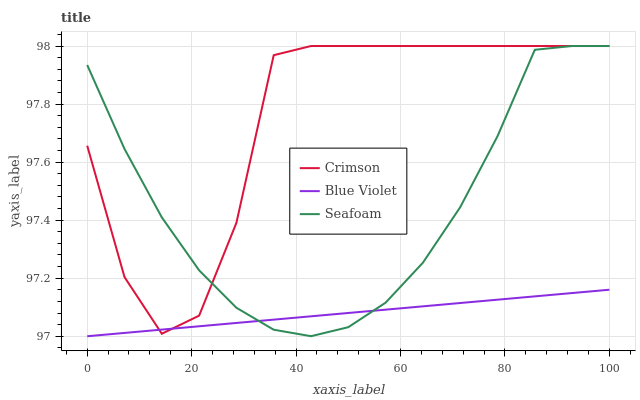Does Blue Violet have the minimum area under the curve?
Answer yes or no. Yes. Does Crimson have the maximum area under the curve?
Answer yes or no. Yes. Does Seafoam have the minimum area under the curve?
Answer yes or no. No. Does Seafoam have the maximum area under the curve?
Answer yes or no. No. Is Blue Violet the smoothest?
Answer yes or no. Yes. Is Crimson the roughest?
Answer yes or no. Yes. Is Seafoam the smoothest?
Answer yes or no. No. Is Seafoam the roughest?
Answer yes or no. No. Does Blue Violet have the lowest value?
Answer yes or no. Yes. Does Seafoam have the lowest value?
Answer yes or no. No. Does Seafoam have the highest value?
Answer yes or no. Yes. Does Blue Violet have the highest value?
Answer yes or no. No. Does Crimson intersect Seafoam?
Answer yes or no. Yes. Is Crimson less than Seafoam?
Answer yes or no. No. Is Crimson greater than Seafoam?
Answer yes or no. No. 